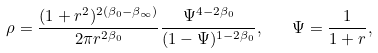Convert formula to latex. <formula><loc_0><loc_0><loc_500><loc_500>\rho = \frac { ( 1 + r ^ { 2 } ) ^ { 2 ( \beta _ { 0 } - \beta _ { \infty } ) } } { 2 \pi r ^ { 2 \beta _ { 0 } } } \frac { \Psi ^ { 4 - 2 \beta _ { 0 } } } { ( 1 - \Psi ) ^ { 1 - 2 \beta _ { 0 } } } , \quad \Psi = \frac { 1 } { 1 + r } ,</formula> 